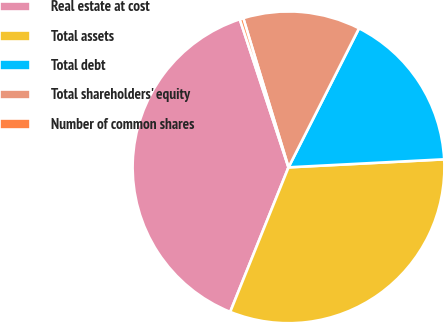<chart> <loc_0><loc_0><loc_500><loc_500><pie_chart><fcel>Real estate at cost<fcel>Total assets<fcel>Total debt<fcel>Total shareholders' equity<fcel>Number of common shares<nl><fcel>38.84%<fcel>31.92%<fcel>16.71%<fcel>12.16%<fcel>0.37%<nl></chart> 